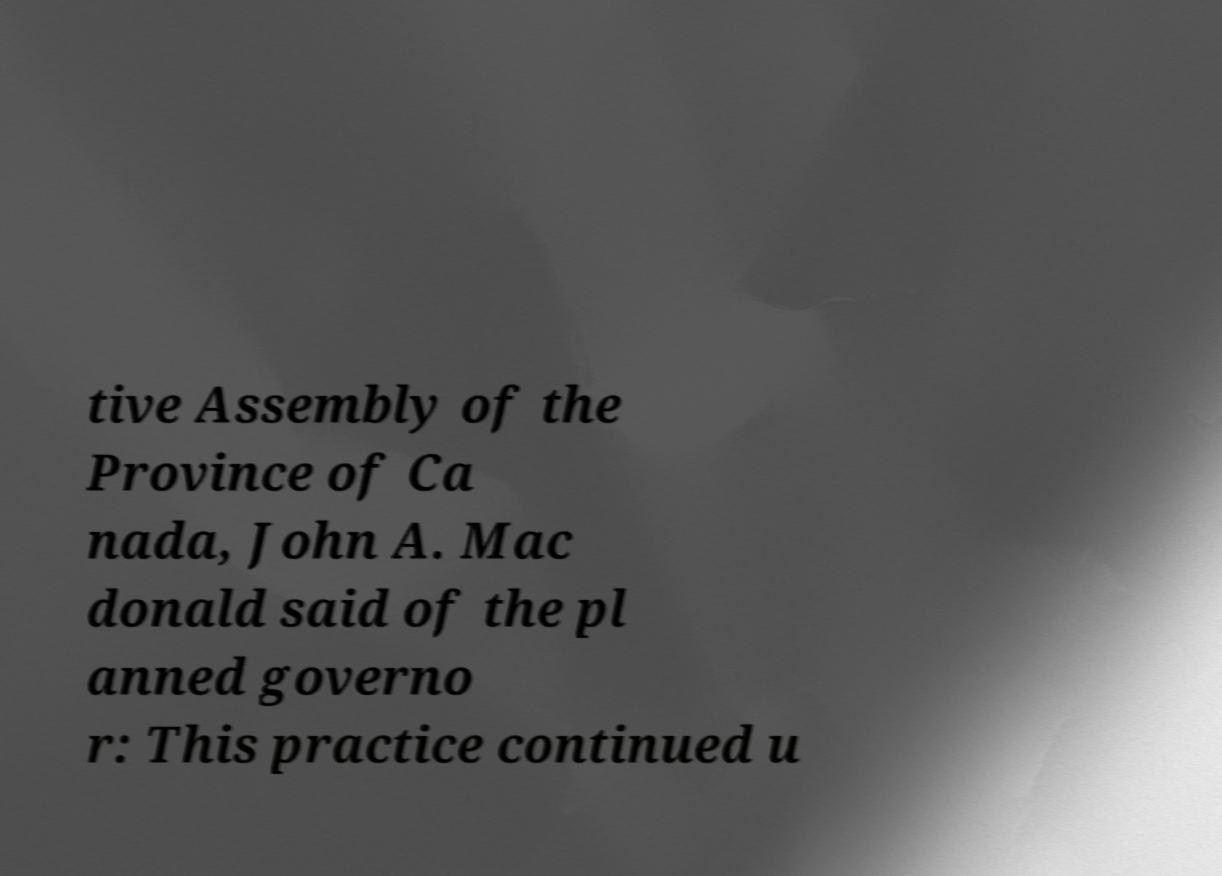I need the written content from this picture converted into text. Can you do that? tive Assembly of the Province of Ca nada, John A. Mac donald said of the pl anned governo r: This practice continued u 